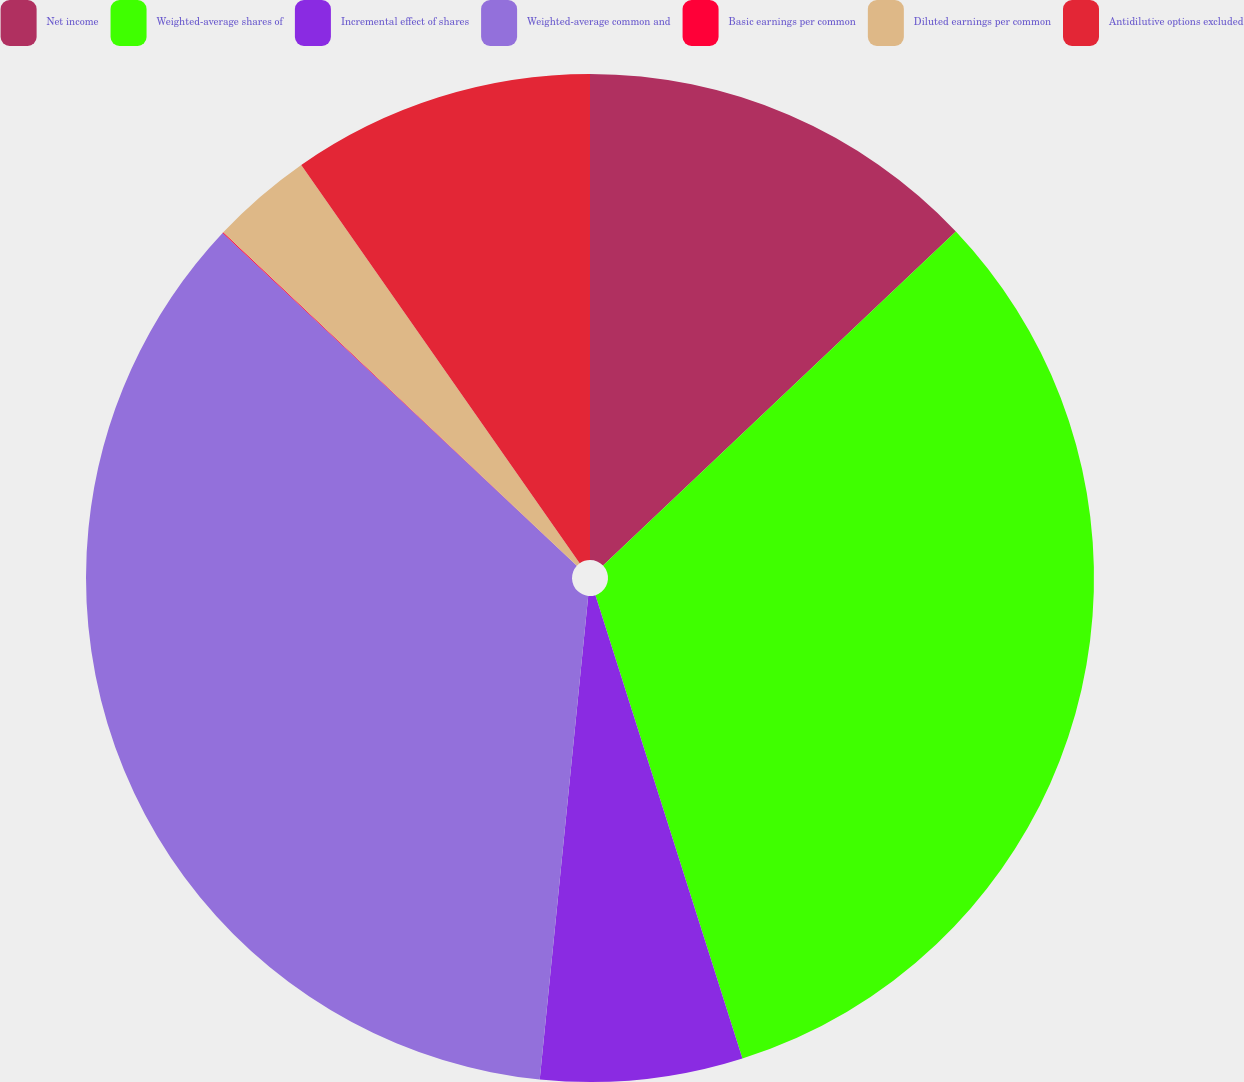<chart> <loc_0><loc_0><loc_500><loc_500><pie_chart><fcel>Net income<fcel>Weighted-average shares of<fcel>Incremental effect of shares<fcel>Weighted-average common and<fcel>Basic earnings per common<fcel>Diluted earnings per common<fcel>Antidilutive options excluded<nl><fcel>12.93%<fcel>32.18%<fcel>6.48%<fcel>35.41%<fcel>0.03%<fcel>3.26%<fcel>9.71%<nl></chart> 